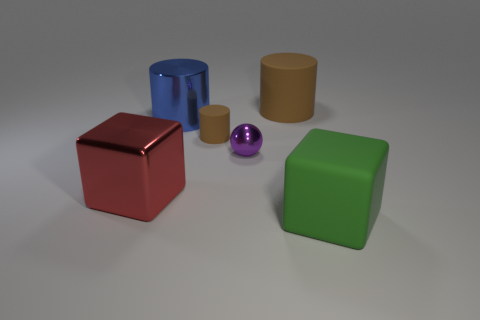If this were a photo in a product catalog, what information might be included in the description? If this image was in a product catalog, the description would likely include the name and function of each item, the materials they are made of, dimensions, color options, and perhaps some care instructions or usage tips, alongside pricing and availability details. 